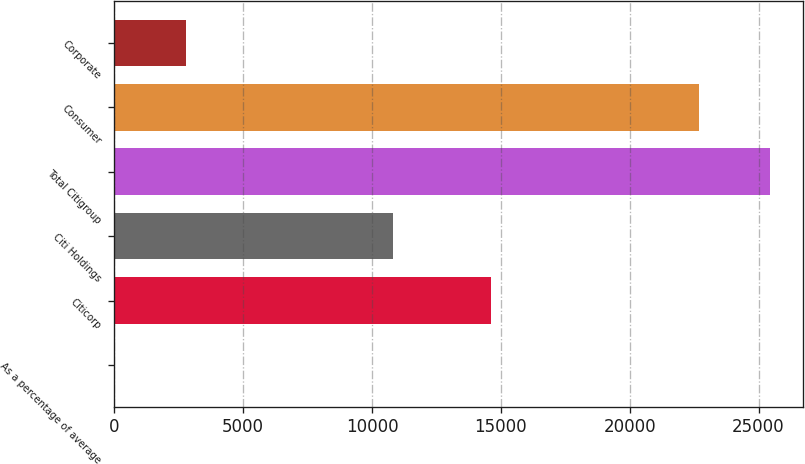<chart> <loc_0><loc_0><loc_500><loc_500><bar_chart><fcel>As a percentage of average<fcel>Citicorp<fcel>Citi Holdings<fcel>Total Citigroup<fcel>Consumer<fcel>Corporate<nl><fcel>0.09<fcel>14623<fcel>10832<fcel>25455<fcel>22679<fcel>2776<nl></chart> 